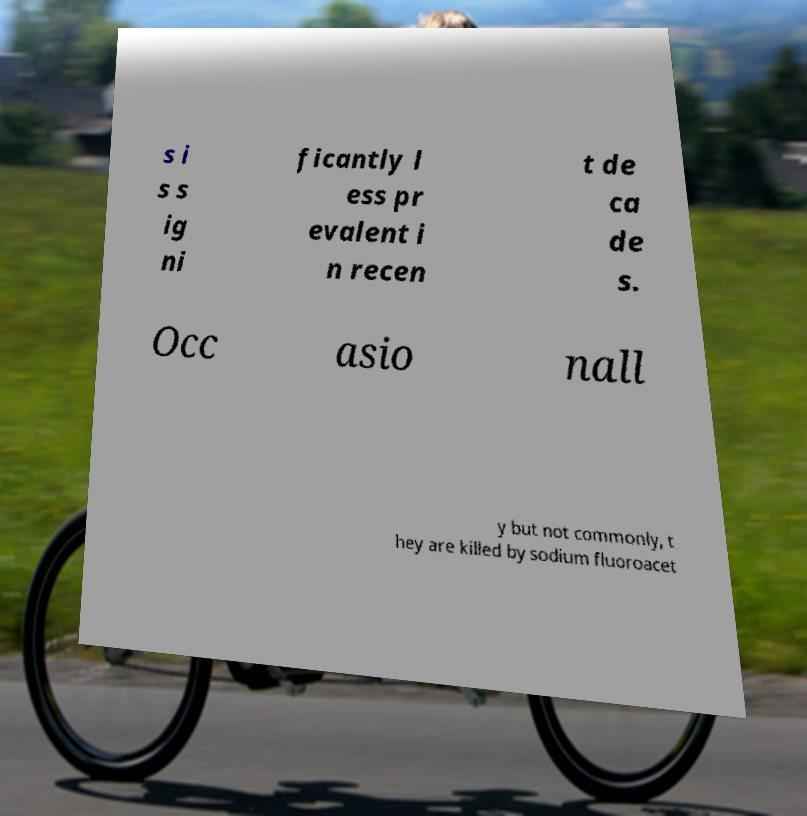I need the written content from this picture converted into text. Can you do that? s i s s ig ni ficantly l ess pr evalent i n recen t de ca de s. Occ asio nall y but not commonly, t hey are killed by sodium fluoroacet 